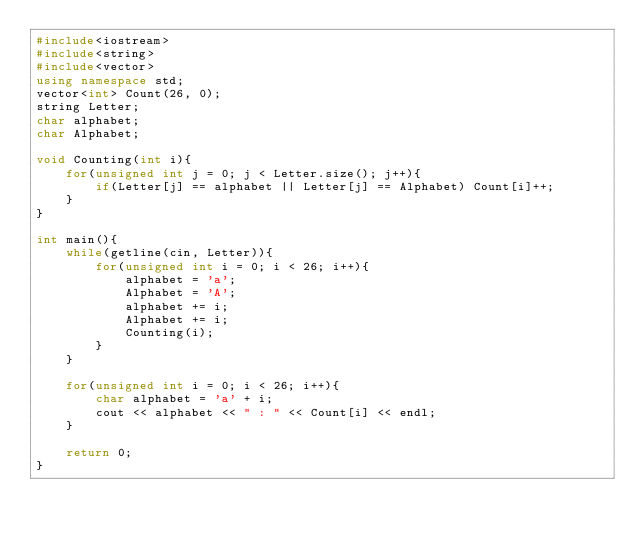Convert code to text. <code><loc_0><loc_0><loc_500><loc_500><_C++_>#include<iostream>
#include<string>
#include<vector>
using namespace std;
vector<int> Count(26, 0);
string Letter;
char alphabet;
char Alphabet;

void Counting(int i){
	for(unsigned int j = 0; j < Letter.size(); j++){
		if(Letter[j] == alphabet || Letter[j] == Alphabet) Count[i]++;
	}
}

int main(){
	while(getline(cin, Letter)){
		for(unsigned int i = 0; i < 26; i++){
			alphabet = 'a';
			Alphabet = 'A';
			alphabet += i;
			Alphabet += i;
			Counting(i);
		}
	}

	for(unsigned int i = 0; i < 26; i++){
		char alphabet = 'a' + i;
		cout << alphabet << " : " << Count[i] << endl;
	}

	return 0;
}</code> 